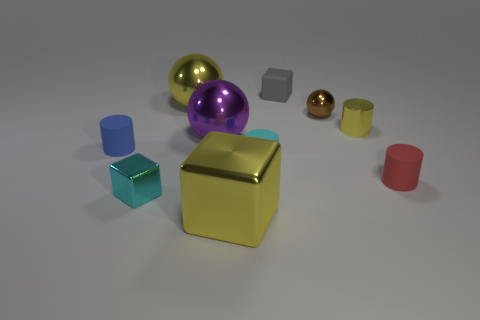Subtract all shiny blocks. How many blocks are left? 1 Subtract all brown balls. How many balls are left? 2 Add 10 gray rubber cylinders. How many gray rubber cylinders exist? 10 Subtract 0 red blocks. How many objects are left? 10 Subtract all blocks. How many objects are left? 7 Subtract all cyan cylinders. Subtract all gray spheres. How many cylinders are left? 3 Subtract all brown cylinders. Subtract all big yellow objects. How many objects are left? 8 Add 6 yellow metal balls. How many yellow metal balls are left? 7 